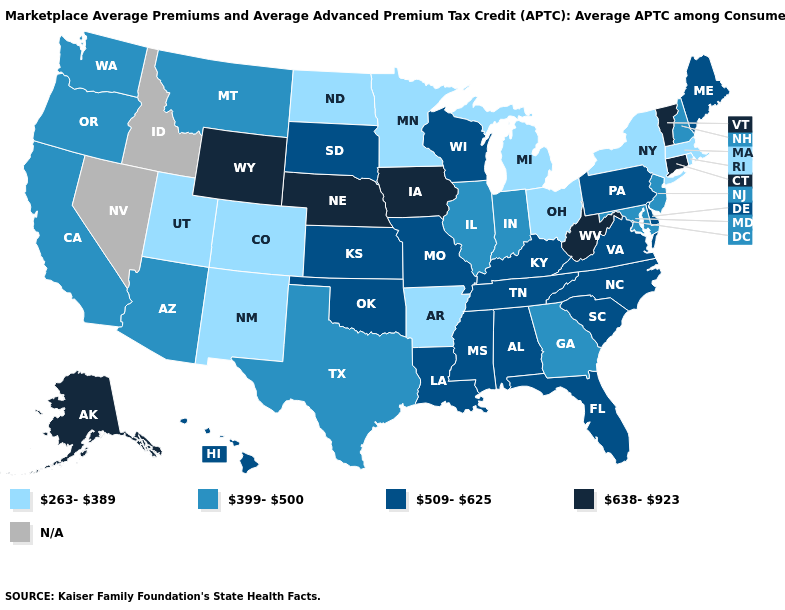What is the value of Nevada?
Be succinct. N/A. Which states have the highest value in the USA?
Concise answer only. Alaska, Connecticut, Iowa, Nebraska, Vermont, West Virginia, Wyoming. Name the states that have a value in the range 509-625?
Keep it brief. Alabama, Delaware, Florida, Hawaii, Kansas, Kentucky, Louisiana, Maine, Mississippi, Missouri, North Carolina, Oklahoma, Pennsylvania, South Carolina, South Dakota, Tennessee, Virginia, Wisconsin. What is the highest value in states that border Delaware?
Be succinct. 509-625. Does Michigan have the highest value in the USA?
Write a very short answer. No. Does the map have missing data?
Give a very brief answer. Yes. Does Washington have the highest value in the USA?
Give a very brief answer. No. Is the legend a continuous bar?
Write a very short answer. No. What is the lowest value in the South?
Short answer required. 263-389. Which states have the lowest value in the Northeast?
Keep it brief. Massachusetts, New York, Rhode Island. What is the value of Ohio?
Answer briefly. 263-389. Name the states that have a value in the range 638-923?
Give a very brief answer. Alaska, Connecticut, Iowa, Nebraska, Vermont, West Virginia, Wyoming. What is the highest value in the USA?
Quick response, please. 638-923. Does Ohio have the lowest value in the MidWest?
Write a very short answer. Yes. 